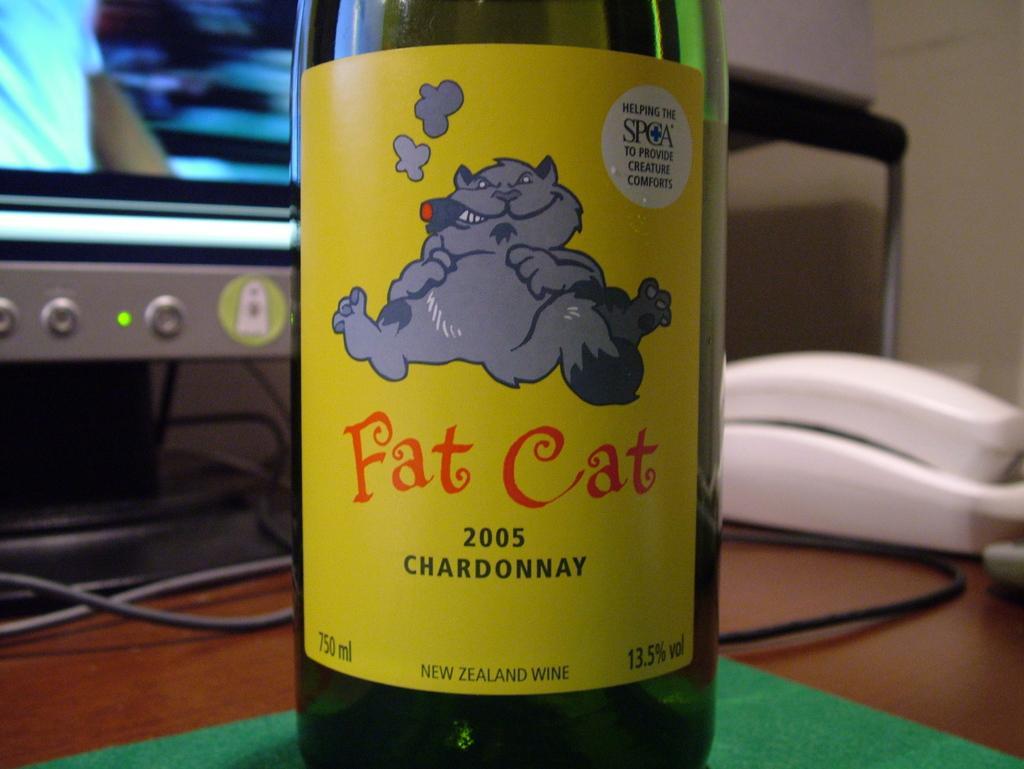Could you give a brief overview of what you see in this image? In the foreground of this picture, there is a bottle on a table and in the background, there is a land phone, monitor and cables. 